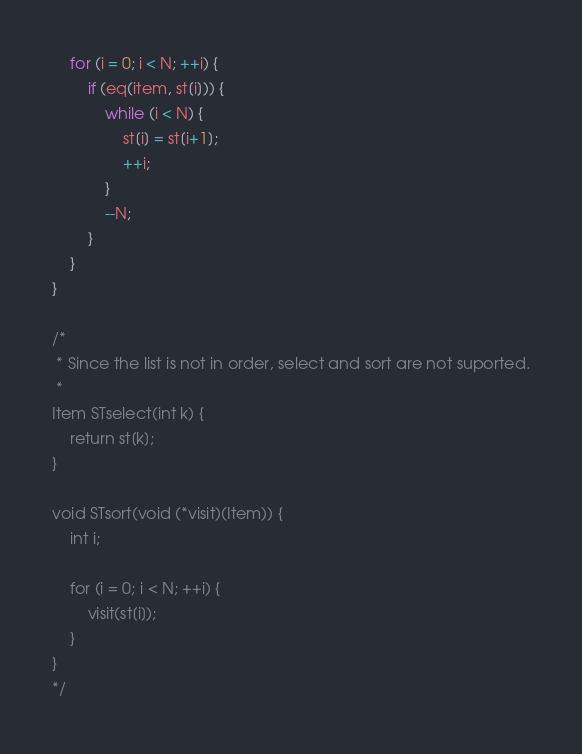Convert code to text. <code><loc_0><loc_0><loc_500><loc_500><_C_>	for (i = 0; i < N; ++i) {
		if (eq(item, st[i])) {
			while (i < N) {
				st[i] = st[i+1];
				++i;
			}
			--N;
		}
	}
}

/* 
 * Since the list is not in order, select and sort are not suported.
 * 
Item STselect(int k) {
	return st[k];
}

void STsort(void (*visit)(Item)) {
	int i;
	
	for (i = 0; i < N; ++i) {
		visit(st[i]);
	}
}
*/
</code> 